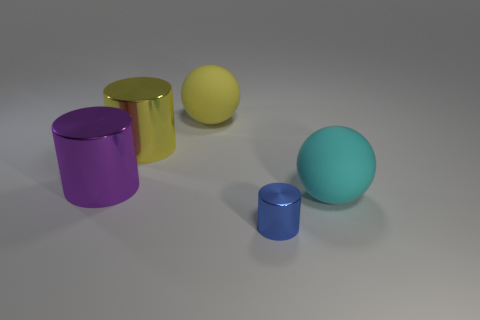Is the number of purple cylinders in front of the purple cylinder the same as the number of tiny blue metallic cylinders?
Provide a short and direct response. No. Is there anything else that is made of the same material as the purple thing?
Ensure brevity in your answer.  Yes. What number of big things are purple shiny things or cyan matte things?
Make the answer very short. 2. Is the large yellow cylinder behind the blue cylinder made of the same material as the cyan object?
Your response must be concise. No. Are there an equal number of large purple cylinders and big brown rubber things?
Provide a short and direct response. No. What material is the cylinder in front of the cylinder on the left side of the yellow cylinder?
Give a very brief answer. Metal. What number of other small things are the same shape as the blue metal thing?
Offer a very short reply. 0. There is a matte thing on the left side of the shiny object that is in front of the rubber sphere that is to the right of the blue metallic thing; what size is it?
Give a very brief answer. Large. How many yellow objects are either tiny shiny cylinders or balls?
Your response must be concise. 1. Do the thing that is in front of the large cyan matte sphere and the big yellow metallic thing have the same shape?
Your answer should be compact. Yes. 